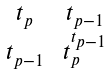<formula> <loc_0><loc_0><loc_500><loc_500>\begin{smallmatrix} t _ { p } & & t _ { p - 1 } \\ t _ { p - 1 } & & t _ { p } ^ { t _ { p - 1 } } \end{smallmatrix}</formula> 